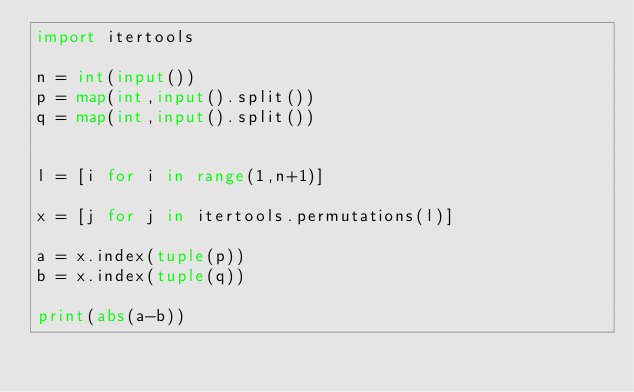<code> <loc_0><loc_0><loc_500><loc_500><_Python_>import itertools

n = int(input())
p = map(int,input().split())
q = map(int,input().split())


l = [i for i in range(1,n+1)]

x = [j for j in itertools.permutations(l)]

a = x.index(tuple(p))
b = x.index(tuple(q))

print(abs(a-b))
</code> 